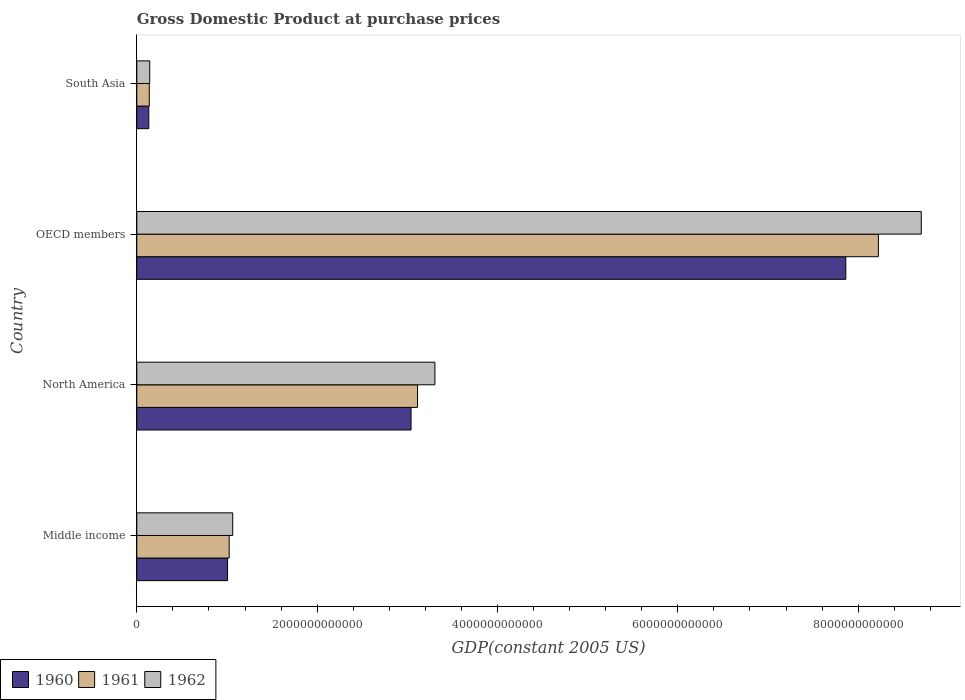Are the number of bars per tick equal to the number of legend labels?
Offer a terse response. Yes. Are the number of bars on each tick of the Y-axis equal?
Your answer should be very brief. Yes. What is the label of the 3rd group of bars from the top?
Give a very brief answer. North America. What is the GDP at purchase prices in 1961 in OECD members?
Offer a very short reply. 8.22e+12. Across all countries, what is the maximum GDP at purchase prices in 1960?
Give a very brief answer. 7.86e+12. Across all countries, what is the minimum GDP at purchase prices in 1961?
Offer a very short reply. 1.39e+11. What is the total GDP at purchase prices in 1960 in the graph?
Offer a terse response. 1.20e+13. What is the difference between the GDP at purchase prices in 1960 in North America and that in South Asia?
Keep it short and to the point. 2.91e+12. What is the difference between the GDP at purchase prices in 1961 in Middle income and the GDP at purchase prices in 1962 in OECD members?
Ensure brevity in your answer.  -7.68e+12. What is the average GDP at purchase prices in 1962 per country?
Offer a very short reply. 3.30e+12. What is the difference between the GDP at purchase prices in 1962 and GDP at purchase prices in 1961 in Middle income?
Your answer should be compact. 3.94e+1. In how many countries, is the GDP at purchase prices in 1960 greater than 2400000000000 US$?
Offer a terse response. 2. What is the ratio of the GDP at purchase prices in 1960 in OECD members to that in South Asia?
Your response must be concise. 59.05. What is the difference between the highest and the second highest GDP at purchase prices in 1962?
Give a very brief answer. 5.39e+12. What is the difference between the highest and the lowest GDP at purchase prices in 1961?
Ensure brevity in your answer.  8.09e+12. In how many countries, is the GDP at purchase prices in 1961 greater than the average GDP at purchase prices in 1961 taken over all countries?
Offer a very short reply. 1. What does the 3rd bar from the bottom in South Asia represents?
Ensure brevity in your answer.  1962. How many bars are there?
Offer a terse response. 12. How many countries are there in the graph?
Offer a very short reply. 4. What is the difference between two consecutive major ticks on the X-axis?
Offer a terse response. 2.00e+12. Does the graph contain grids?
Your answer should be compact. No. How many legend labels are there?
Your response must be concise. 3. What is the title of the graph?
Your answer should be very brief. Gross Domestic Product at purchase prices. Does "1963" appear as one of the legend labels in the graph?
Provide a succinct answer. No. What is the label or title of the X-axis?
Provide a short and direct response. GDP(constant 2005 US). What is the GDP(constant 2005 US) in 1960 in Middle income?
Provide a succinct answer. 1.01e+12. What is the GDP(constant 2005 US) in 1961 in Middle income?
Give a very brief answer. 1.02e+12. What is the GDP(constant 2005 US) in 1962 in Middle income?
Make the answer very short. 1.06e+12. What is the GDP(constant 2005 US) in 1960 in North America?
Make the answer very short. 3.04e+12. What is the GDP(constant 2005 US) in 1961 in North America?
Give a very brief answer. 3.11e+12. What is the GDP(constant 2005 US) of 1962 in North America?
Provide a short and direct response. 3.31e+12. What is the GDP(constant 2005 US) of 1960 in OECD members?
Provide a succinct answer. 7.86e+12. What is the GDP(constant 2005 US) in 1961 in OECD members?
Ensure brevity in your answer.  8.22e+12. What is the GDP(constant 2005 US) of 1962 in OECD members?
Keep it short and to the point. 8.70e+12. What is the GDP(constant 2005 US) of 1960 in South Asia?
Ensure brevity in your answer.  1.33e+11. What is the GDP(constant 2005 US) of 1961 in South Asia?
Provide a short and direct response. 1.39e+11. What is the GDP(constant 2005 US) of 1962 in South Asia?
Your answer should be compact. 1.43e+11. Across all countries, what is the maximum GDP(constant 2005 US) in 1960?
Keep it short and to the point. 7.86e+12. Across all countries, what is the maximum GDP(constant 2005 US) of 1961?
Your answer should be compact. 8.22e+12. Across all countries, what is the maximum GDP(constant 2005 US) of 1962?
Provide a short and direct response. 8.70e+12. Across all countries, what is the minimum GDP(constant 2005 US) in 1960?
Ensure brevity in your answer.  1.33e+11. Across all countries, what is the minimum GDP(constant 2005 US) of 1961?
Ensure brevity in your answer.  1.39e+11. Across all countries, what is the minimum GDP(constant 2005 US) of 1962?
Keep it short and to the point. 1.43e+11. What is the total GDP(constant 2005 US) in 1960 in the graph?
Give a very brief answer. 1.20e+13. What is the total GDP(constant 2005 US) of 1961 in the graph?
Your answer should be very brief. 1.25e+13. What is the total GDP(constant 2005 US) of 1962 in the graph?
Your answer should be compact. 1.32e+13. What is the difference between the GDP(constant 2005 US) of 1960 in Middle income and that in North America?
Make the answer very short. -2.03e+12. What is the difference between the GDP(constant 2005 US) of 1961 in Middle income and that in North America?
Your answer should be very brief. -2.09e+12. What is the difference between the GDP(constant 2005 US) of 1962 in Middle income and that in North America?
Ensure brevity in your answer.  -2.24e+12. What is the difference between the GDP(constant 2005 US) in 1960 in Middle income and that in OECD members?
Your response must be concise. -6.86e+12. What is the difference between the GDP(constant 2005 US) of 1961 in Middle income and that in OECD members?
Provide a short and direct response. -7.20e+12. What is the difference between the GDP(constant 2005 US) in 1962 in Middle income and that in OECD members?
Your response must be concise. -7.64e+12. What is the difference between the GDP(constant 2005 US) of 1960 in Middle income and that in South Asia?
Your response must be concise. 8.74e+11. What is the difference between the GDP(constant 2005 US) of 1961 in Middle income and that in South Asia?
Keep it short and to the point. 8.86e+11. What is the difference between the GDP(constant 2005 US) of 1962 in Middle income and that in South Asia?
Provide a succinct answer. 9.20e+11. What is the difference between the GDP(constant 2005 US) of 1960 in North America and that in OECD members?
Make the answer very short. -4.82e+12. What is the difference between the GDP(constant 2005 US) in 1961 in North America and that in OECD members?
Provide a succinct answer. -5.11e+12. What is the difference between the GDP(constant 2005 US) of 1962 in North America and that in OECD members?
Provide a short and direct response. -5.39e+12. What is the difference between the GDP(constant 2005 US) in 1960 in North America and that in South Asia?
Ensure brevity in your answer.  2.91e+12. What is the difference between the GDP(constant 2005 US) of 1961 in North America and that in South Asia?
Your answer should be compact. 2.97e+12. What is the difference between the GDP(constant 2005 US) of 1962 in North America and that in South Asia?
Your response must be concise. 3.16e+12. What is the difference between the GDP(constant 2005 US) of 1960 in OECD members and that in South Asia?
Your response must be concise. 7.73e+12. What is the difference between the GDP(constant 2005 US) of 1961 in OECD members and that in South Asia?
Your answer should be very brief. 8.09e+12. What is the difference between the GDP(constant 2005 US) in 1962 in OECD members and that in South Asia?
Your answer should be compact. 8.56e+12. What is the difference between the GDP(constant 2005 US) of 1960 in Middle income and the GDP(constant 2005 US) of 1961 in North America?
Provide a succinct answer. -2.11e+12. What is the difference between the GDP(constant 2005 US) in 1960 in Middle income and the GDP(constant 2005 US) in 1962 in North America?
Your answer should be very brief. -2.30e+12. What is the difference between the GDP(constant 2005 US) of 1961 in Middle income and the GDP(constant 2005 US) of 1962 in North America?
Your answer should be very brief. -2.28e+12. What is the difference between the GDP(constant 2005 US) in 1960 in Middle income and the GDP(constant 2005 US) in 1961 in OECD members?
Make the answer very short. -7.22e+12. What is the difference between the GDP(constant 2005 US) in 1960 in Middle income and the GDP(constant 2005 US) in 1962 in OECD members?
Offer a terse response. -7.69e+12. What is the difference between the GDP(constant 2005 US) of 1961 in Middle income and the GDP(constant 2005 US) of 1962 in OECD members?
Provide a short and direct response. -7.68e+12. What is the difference between the GDP(constant 2005 US) of 1960 in Middle income and the GDP(constant 2005 US) of 1961 in South Asia?
Offer a terse response. 8.68e+11. What is the difference between the GDP(constant 2005 US) of 1960 in Middle income and the GDP(constant 2005 US) of 1962 in South Asia?
Keep it short and to the point. 8.63e+11. What is the difference between the GDP(constant 2005 US) in 1961 in Middle income and the GDP(constant 2005 US) in 1962 in South Asia?
Ensure brevity in your answer.  8.81e+11. What is the difference between the GDP(constant 2005 US) in 1960 in North America and the GDP(constant 2005 US) in 1961 in OECD members?
Ensure brevity in your answer.  -5.18e+12. What is the difference between the GDP(constant 2005 US) of 1960 in North America and the GDP(constant 2005 US) of 1962 in OECD members?
Provide a succinct answer. -5.66e+12. What is the difference between the GDP(constant 2005 US) in 1961 in North America and the GDP(constant 2005 US) in 1962 in OECD members?
Provide a succinct answer. -5.59e+12. What is the difference between the GDP(constant 2005 US) in 1960 in North America and the GDP(constant 2005 US) in 1961 in South Asia?
Give a very brief answer. 2.90e+12. What is the difference between the GDP(constant 2005 US) in 1960 in North America and the GDP(constant 2005 US) in 1962 in South Asia?
Offer a very short reply. 2.90e+12. What is the difference between the GDP(constant 2005 US) of 1961 in North America and the GDP(constant 2005 US) of 1962 in South Asia?
Give a very brief answer. 2.97e+12. What is the difference between the GDP(constant 2005 US) in 1960 in OECD members and the GDP(constant 2005 US) in 1961 in South Asia?
Your answer should be very brief. 7.72e+12. What is the difference between the GDP(constant 2005 US) in 1960 in OECD members and the GDP(constant 2005 US) in 1962 in South Asia?
Your response must be concise. 7.72e+12. What is the difference between the GDP(constant 2005 US) of 1961 in OECD members and the GDP(constant 2005 US) of 1962 in South Asia?
Ensure brevity in your answer.  8.08e+12. What is the average GDP(constant 2005 US) in 1960 per country?
Provide a short and direct response. 3.01e+12. What is the average GDP(constant 2005 US) in 1961 per country?
Your response must be concise. 3.13e+12. What is the average GDP(constant 2005 US) in 1962 per country?
Make the answer very short. 3.30e+12. What is the difference between the GDP(constant 2005 US) in 1960 and GDP(constant 2005 US) in 1961 in Middle income?
Offer a very short reply. -1.77e+1. What is the difference between the GDP(constant 2005 US) in 1960 and GDP(constant 2005 US) in 1962 in Middle income?
Offer a very short reply. -5.71e+1. What is the difference between the GDP(constant 2005 US) in 1961 and GDP(constant 2005 US) in 1962 in Middle income?
Offer a terse response. -3.94e+1. What is the difference between the GDP(constant 2005 US) of 1960 and GDP(constant 2005 US) of 1961 in North America?
Keep it short and to the point. -7.21e+1. What is the difference between the GDP(constant 2005 US) in 1960 and GDP(constant 2005 US) in 1962 in North America?
Make the answer very short. -2.65e+11. What is the difference between the GDP(constant 2005 US) of 1961 and GDP(constant 2005 US) of 1962 in North America?
Your answer should be compact. -1.92e+11. What is the difference between the GDP(constant 2005 US) in 1960 and GDP(constant 2005 US) in 1961 in OECD members?
Provide a short and direct response. -3.61e+11. What is the difference between the GDP(constant 2005 US) in 1960 and GDP(constant 2005 US) in 1962 in OECD members?
Give a very brief answer. -8.37e+11. What is the difference between the GDP(constant 2005 US) in 1961 and GDP(constant 2005 US) in 1962 in OECD members?
Your response must be concise. -4.75e+11. What is the difference between the GDP(constant 2005 US) of 1960 and GDP(constant 2005 US) of 1961 in South Asia?
Provide a short and direct response. -5.51e+09. What is the difference between the GDP(constant 2005 US) of 1960 and GDP(constant 2005 US) of 1962 in South Asia?
Keep it short and to the point. -1.01e+1. What is the difference between the GDP(constant 2005 US) in 1961 and GDP(constant 2005 US) in 1962 in South Asia?
Give a very brief answer. -4.63e+09. What is the ratio of the GDP(constant 2005 US) in 1960 in Middle income to that in North America?
Your response must be concise. 0.33. What is the ratio of the GDP(constant 2005 US) in 1961 in Middle income to that in North America?
Give a very brief answer. 0.33. What is the ratio of the GDP(constant 2005 US) in 1962 in Middle income to that in North America?
Keep it short and to the point. 0.32. What is the ratio of the GDP(constant 2005 US) of 1960 in Middle income to that in OECD members?
Make the answer very short. 0.13. What is the ratio of the GDP(constant 2005 US) in 1961 in Middle income to that in OECD members?
Keep it short and to the point. 0.12. What is the ratio of the GDP(constant 2005 US) in 1962 in Middle income to that in OECD members?
Keep it short and to the point. 0.12. What is the ratio of the GDP(constant 2005 US) of 1960 in Middle income to that in South Asia?
Offer a terse response. 7.56. What is the ratio of the GDP(constant 2005 US) in 1961 in Middle income to that in South Asia?
Ensure brevity in your answer.  7.39. What is the ratio of the GDP(constant 2005 US) in 1962 in Middle income to that in South Asia?
Offer a terse response. 7.42. What is the ratio of the GDP(constant 2005 US) of 1960 in North America to that in OECD members?
Your response must be concise. 0.39. What is the ratio of the GDP(constant 2005 US) of 1961 in North America to that in OECD members?
Keep it short and to the point. 0.38. What is the ratio of the GDP(constant 2005 US) of 1962 in North America to that in OECD members?
Offer a terse response. 0.38. What is the ratio of the GDP(constant 2005 US) of 1960 in North America to that in South Asia?
Provide a short and direct response. 22.84. What is the ratio of the GDP(constant 2005 US) of 1961 in North America to that in South Asia?
Your answer should be very brief. 22.45. What is the ratio of the GDP(constant 2005 US) of 1962 in North America to that in South Asia?
Offer a terse response. 23.07. What is the ratio of the GDP(constant 2005 US) in 1960 in OECD members to that in South Asia?
Give a very brief answer. 59.05. What is the ratio of the GDP(constant 2005 US) of 1961 in OECD members to that in South Asia?
Offer a terse response. 59.31. What is the ratio of the GDP(constant 2005 US) of 1962 in OECD members to that in South Asia?
Keep it short and to the point. 60.71. What is the difference between the highest and the second highest GDP(constant 2005 US) in 1960?
Your answer should be very brief. 4.82e+12. What is the difference between the highest and the second highest GDP(constant 2005 US) in 1961?
Your answer should be compact. 5.11e+12. What is the difference between the highest and the second highest GDP(constant 2005 US) in 1962?
Keep it short and to the point. 5.39e+12. What is the difference between the highest and the lowest GDP(constant 2005 US) in 1960?
Ensure brevity in your answer.  7.73e+12. What is the difference between the highest and the lowest GDP(constant 2005 US) in 1961?
Ensure brevity in your answer.  8.09e+12. What is the difference between the highest and the lowest GDP(constant 2005 US) of 1962?
Your response must be concise. 8.56e+12. 